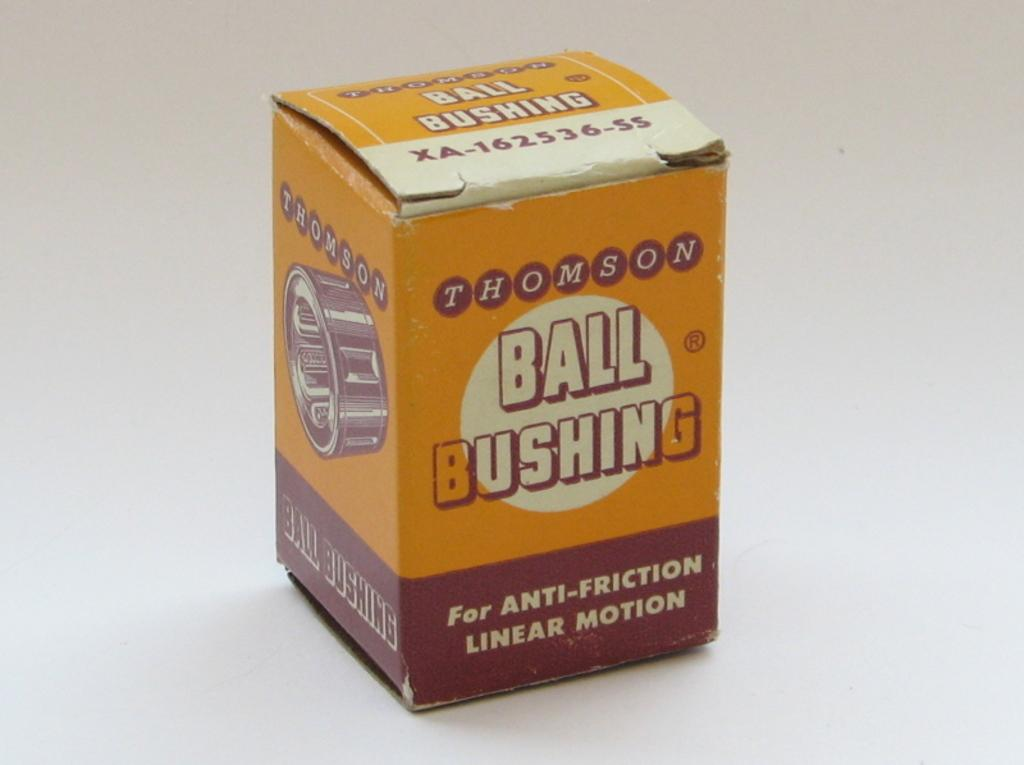<image>
Give a short and clear explanation of the subsequent image. A box containing ball bushings made by Thomson. 